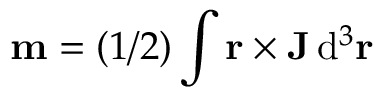Convert formula to latex. <formula><loc_0><loc_0><loc_500><loc_500>\mathbf m = ( 1 / 2 ) \int \mathbf r \times \mathbf J \, d ^ { 3 } \mathbf r</formula> 